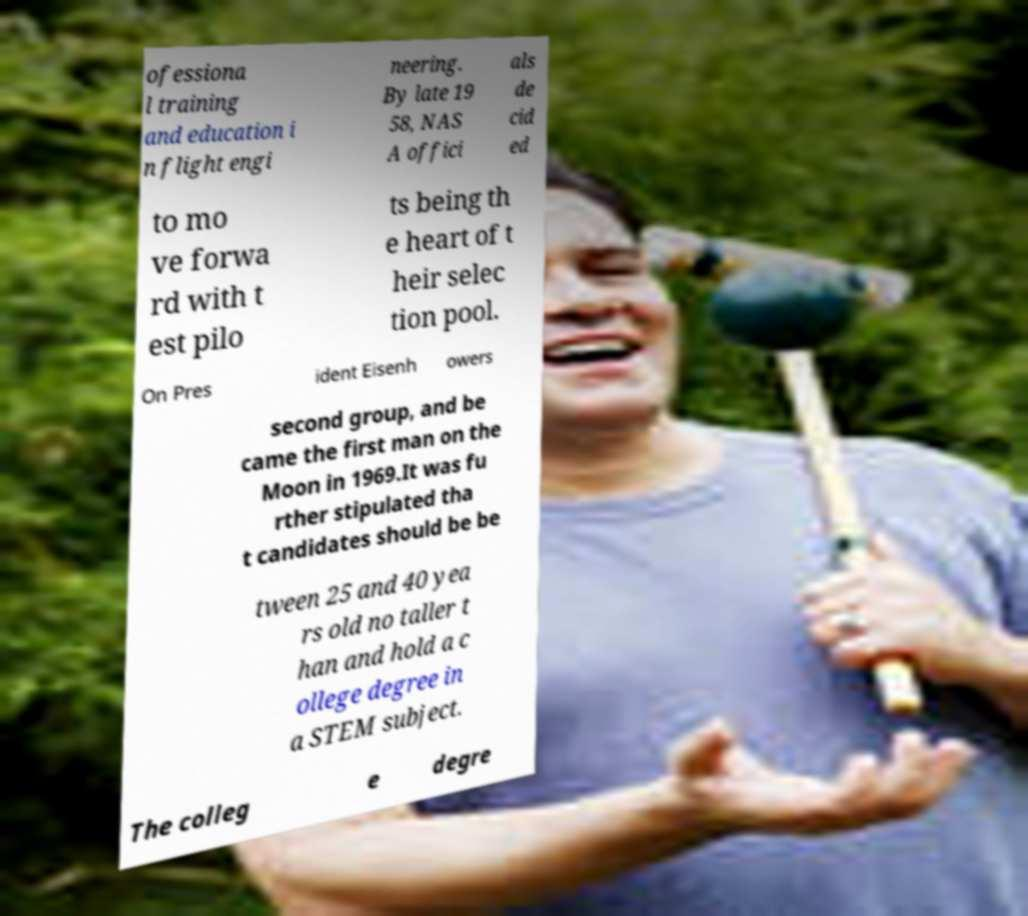What messages or text are displayed in this image? I need them in a readable, typed format. ofessiona l training and education i n flight engi neering. By late 19 58, NAS A offici als de cid ed to mo ve forwa rd with t est pilo ts being th e heart of t heir selec tion pool. On Pres ident Eisenh owers second group, and be came the first man on the Moon in 1969.It was fu rther stipulated tha t candidates should be be tween 25 and 40 yea rs old no taller t han and hold a c ollege degree in a STEM subject. The colleg e degre 